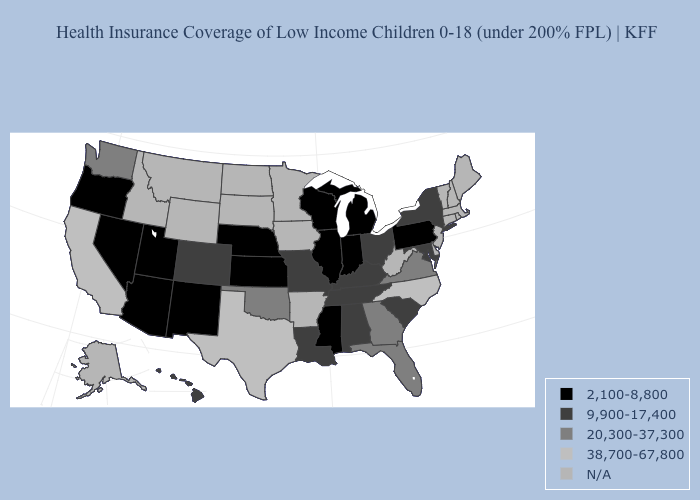What is the value of Maine?
Short answer required. N/A. What is the highest value in states that border Delaware?
Answer briefly. 9,900-17,400. What is the lowest value in states that border Michigan?
Quick response, please. 2,100-8,800. What is the highest value in the West ?
Concise answer only. 38,700-67,800. What is the lowest value in the USA?
Give a very brief answer. 2,100-8,800. Does the map have missing data?
Concise answer only. Yes. Name the states that have a value in the range 20,300-37,300?
Answer briefly. Florida, Georgia, Oklahoma, Virginia, Washington. Name the states that have a value in the range N/A?
Quick response, please. Alaska, Arkansas, Connecticut, Delaware, Idaho, Iowa, Maine, Massachusetts, Minnesota, Montana, New Hampshire, New Jersey, North Dakota, Rhode Island, South Dakota, Vermont, West Virginia, Wyoming. Does Ohio have the lowest value in the MidWest?
Keep it brief. No. Does the first symbol in the legend represent the smallest category?
Write a very short answer. Yes. What is the value of Maryland?
Answer briefly. 9,900-17,400. Does Nevada have the lowest value in the West?
Keep it brief. Yes. Does the map have missing data?
Short answer required. Yes. Name the states that have a value in the range 9,900-17,400?
Be succinct. Alabama, Colorado, Hawaii, Kentucky, Louisiana, Maryland, Missouri, New York, Ohio, South Carolina, Tennessee. What is the highest value in the USA?
Give a very brief answer. 38,700-67,800. 